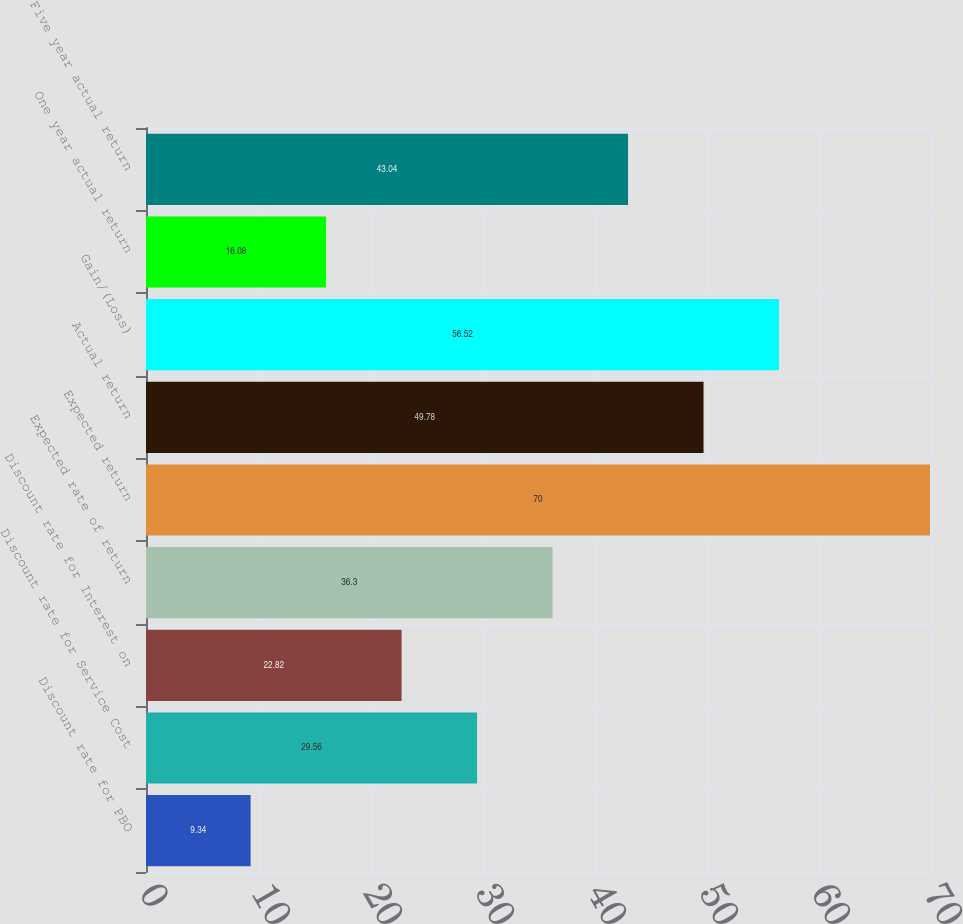Convert chart to OTSL. <chart><loc_0><loc_0><loc_500><loc_500><bar_chart><fcel>Discount rate for PBO<fcel>Discount rate for Service Cost<fcel>Discount rate for Interest on<fcel>Expected rate of return<fcel>Expected return<fcel>Actual return<fcel>Gain/(Loss)<fcel>One year actual return<fcel>Five year actual return<nl><fcel>9.34<fcel>29.56<fcel>22.82<fcel>36.3<fcel>70<fcel>49.78<fcel>56.52<fcel>16.08<fcel>43.04<nl></chart> 